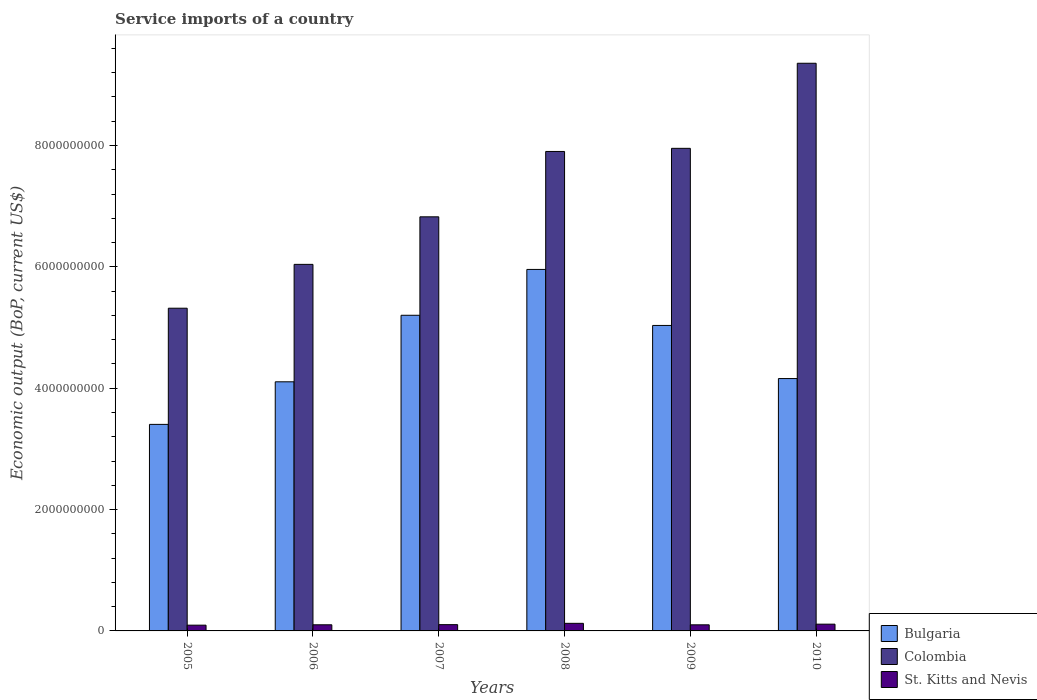How many different coloured bars are there?
Keep it short and to the point. 3. Are the number of bars per tick equal to the number of legend labels?
Your response must be concise. Yes. How many bars are there on the 4th tick from the right?
Make the answer very short. 3. What is the label of the 4th group of bars from the left?
Provide a short and direct response. 2008. In how many cases, is the number of bars for a given year not equal to the number of legend labels?
Your answer should be compact. 0. What is the service imports in Bulgaria in 2009?
Your response must be concise. 5.03e+09. Across all years, what is the maximum service imports in Bulgaria?
Ensure brevity in your answer.  5.96e+09. Across all years, what is the minimum service imports in Bulgaria?
Your answer should be compact. 3.40e+09. In which year was the service imports in Colombia maximum?
Your answer should be compact. 2010. In which year was the service imports in Bulgaria minimum?
Provide a succinct answer. 2005. What is the total service imports in Colombia in the graph?
Provide a succinct answer. 4.34e+1. What is the difference between the service imports in St. Kitts and Nevis in 2007 and that in 2009?
Keep it short and to the point. 2.91e+06. What is the difference between the service imports in Colombia in 2010 and the service imports in Bulgaria in 2006?
Offer a terse response. 5.25e+09. What is the average service imports in Bulgaria per year?
Your response must be concise. 4.64e+09. In the year 2009, what is the difference between the service imports in St. Kitts and Nevis and service imports in Colombia?
Offer a terse response. -7.85e+09. What is the ratio of the service imports in Bulgaria in 2006 to that in 2008?
Your answer should be compact. 0.69. What is the difference between the highest and the second highest service imports in Colombia?
Your response must be concise. 1.40e+09. What is the difference between the highest and the lowest service imports in Bulgaria?
Provide a short and direct response. 2.55e+09. In how many years, is the service imports in Bulgaria greater than the average service imports in Bulgaria taken over all years?
Offer a terse response. 3. Is the sum of the service imports in Bulgaria in 2005 and 2009 greater than the maximum service imports in Colombia across all years?
Give a very brief answer. No. What does the 3rd bar from the left in 2005 represents?
Offer a terse response. St. Kitts and Nevis. What does the 3rd bar from the right in 2009 represents?
Ensure brevity in your answer.  Bulgaria. Is it the case that in every year, the sum of the service imports in St. Kitts and Nevis and service imports in Bulgaria is greater than the service imports in Colombia?
Your response must be concise. No. Are all the bars in the graph horizontal?
Ensure brevity in your answer.  No. How many years are there in the graph?
Provide a succinct answer. 6. Does the graph contain grids?
Make the answer very short. No. Where does the legend appear in the graph?
Your response must be concise. Bottom right. How many legend labels are there?
Provide a short and direct response. 3. How are the legend labels stacked?
Ensure brevity in your answer.  Vertical. What is the title of the graph?
Your response must be concise. Service imports of a country. Does "El Salvador" appear as one of the legend labels in the graph?
Your response must be concise. No. What is the label or title of the Y-axis?
Your answer should be very brief. Economic output (BoP, current US$). What is the Economic output (BoP, current US$) of Bulgaria in 2005?
Your answer should be very brief. 3.40e+09. What is the Economic output (BoP, current US$) in Colombia in 2005?
Offer a terse response. 5.32e+09. What is the Economic output (BoP, current US$) in St. Kitts and Nevis in 2005?
Your response must be concise. 9.49e+07. What is the Economic output (BoP, current US$) of Bulgaria in 2006?
Offer a terse response. 4.11e+09. What is the Economic output (BoP, current US$) in Colombia in 2006?
Your answer should be compact. 6.04e+09. What is the Economic output (BoP, current US$) of St. Kitts and Nevis in 2006?
Keep it short and to the point. 1.01e+08. What is the Economic output (BoP, current US$) of Bulgaria in 2007?
Give a very brief answer. 5.20e+09. What is the Economic output (BoP, current US$) of Colombia in 2007?
Keep it short and to the point. 6.82e+09. What is the Economic output (BoP, current US$) of St. Kitts and Nevis in 2007?
Offer a terse response. 1.03e+08. What is the Economic output (BoP, current US$) in Bulgaria in 2008?
Provide a short and direct response. 5.96e+09. What is the Economic output (BoP, current US$) in Colombia in 2008?
Your answer should be compact. 7.90e+09. What is the Economic output (BoP, current US$) in St. Kitts and Nevis in 2008?
Your answer should be very brief. 1.25e+08. What is the Economic output (BoP, current US$) of Bulgaria in 2009?
Keep it short and to the point. 5.03e+09. What is the Economic output (BoP, current US$) in Colombia in 2009?
Provide a short and direct response. 7.95e+09. What is the Economic output (BoP, current US$) in St. Kitts and Nevis in 2009?
Offer a terse response. 1.00e+08. What is the Economic output (BoP, current US$) in Bulgaria in 2010?
Offer a very short reply. 4.16e+09. What is the Economic output (BoP, current US$) of Colombia in 2010?
Give a very brief answer. 9.36e+09. What is the Economic output (BoP, current US$) in St. Kitts and Nevis in 2010?
Make the answer very short. 1.11e+08. Across all years, what is the maximum Economic output (BoP, current US$) in Bulgaria?
Offer a very short reply. 5.96e+09. Across all years, what is the maximum Economic output (BoP, current US$) of Colombia?
Your response must be concise. 9.36e+09. Across all years, what is the maximum Economic output (BoP, current US$) in St. Kitts and Nevis?
Provide a succinct answer. 1.25e+08. Across all years, what is the minimum Economic output (BoP, current US$) of Bulgaria?
Provide a succinct answer. 3.40e+09. Across all years, what is the minimum Economic output (BoP, current US$) in Colombia?
Ensure brevity in your answer.  5.32e+09. Across all years, what is the minimum Economic output (BoP, current US$) in St. Kitts and Nevis?
Make the answer very short. 9.49e+07. What is the total Economic output (BoP, current US$) of Bulgaria in the graph?
Offer a very short reply. 2.79e+1. What is the total Economic output (BoP, current US$) of Colombia in the graph?
Your answer should be very brief. 4.34e+1. What is the total Economic output (BoP, current US$) in St. Kitts and Nevis in the graph?
Your answer should be very brief. 6.36e+08. What is the difference between the Economic output (BoP, current US$) in Bulgaria in 2005 and that in 2006?
Ensure brevity in your answer.  -7.02e+08. What is the difference between the Economic output (BoP, current US$) in Colombia in 2005 and that in 2006?
Offer a very short reply. -7.23e+08. What is the difference between the Economic output (BoP, current US$) in St. Kitts and Nevis in 2005 and that in 2006?
Your response must be concise. -6.20e+06. What is the difference between the Economic output (BoP, current US$) in Bulgaria in 2005 and that in 2007?
Keep it short and to the point. -1.80e+09. What is the difference between the Economic output (BoP, current US$) in Colombia in 2005 and that in 2007?
Give a very brief answer. -1.51e+09. What is the difference between the Economic output (BoP, current US$) of St. Kitts and Nevis in 2005 and that in 2007?
Your answer should be very brief. -8.45e+06. What is the difference between the Economic output (BoP, current US$) of Bulgaria in 2005 and that in 2008?
Keep it short and to the point. -2.55e+09. What is the difference between the Economic output (BoP, current US$) in Colombia in 2005 and that in 2008?
Offer a terse response. -2.58e+09. What is the difference between the Economic output (BoP, current US$) in St. Kitts and Nevis in 2005 and that in 2008?
Give a very brief answer. -3.02e+07. What is the difference between the Economic output (BoP, current US$) of Bulgaria in 2005 and that in 2009?
Offer a very short reply. -1.63e+09. What is the difference between the Economic output (BoP, current US$) in Colombia in 2005 and that in 2009?
Provide a short and direct response. -2.63e+09. What is the difference between the Economic output (BoP, current US$) in St. Kitts and Nevis in 2005 and that in 2009?
Your answer should be very brief. -5.54e+06. What is the difference between the Economic output (BoP, current US$) of Bulgaria in 2005 and that in 2010?
Your answer should be compact. -7.55e+08. What is the difference between the Economic output (BoP, current US$) in Colombia in 2005 and that in 2010?
Offer a very short reply. -4.04e+09. What is the difference between the Economic output (BoP, current US$) in St. Kitts and Nevis in 2005 and that in 2010?
Make the answer very short. -1.65e+07. What is the difference between the Economic output (BoP, current US$) in Bulgaria in 2006 and that in 2007?
Your answer should be very brief. -1.10e+09. What is the difference between the Economic output (BoP, current US$) in Colombia in 2006 and that in 2007?
Your response must be concise. -7.84e+08. What is the difference between the Economic output (BoP, current US$) in St. Kitts and Nevis in 2006 and that in 2007?
Your response must be concise. -2.25e+06. What is the difference between the Economic output (BoP, current US$) of Bulgaria in 2006 and that in 2008?
Make the answer very short. -1.85e+09. What is the difference between the Economic output (BoP, current US$) of Colombia in 2006 and that in 2008?
Your answer should be very brief. -1.86e+09. What is the difference between the Economic output (BoP, current US$) in St. Kitts and Nevis in 2006 and that in 2008?
Provide a short and direct response. -2.40e+07. What is the difference between the Economic output (BoP, current US$) of Bulgaria in 2006 and that in 2009?
Ensure brevity in your answer.  -9.29e+08. What is the difference between the Economic output (BoP, current US$) in Colombia in 2006 and that in 2009?
Your answer should be compact. -1.91e+09. What is the difference between the Economic output (BoP, current US$) in St. Kitts and Nevis in 2006 and that in 2009?
Give a very brief answer. 6.64e+05. What is the difference between the Economic output (BoP, current US$) in Bulgaria in 2006 and that in 2010?
Offer a terse response. -5.36e+07. What is the difference between the Economic output (BoP, current US$) of Colombia in 2006 and that in 2010?
Your answer should be compact. -3.31e+09. What is the difference between the Economic output (BoP, current US$) in St. Kitts and Nevis in 2006 and that in 2010?
Your answer should be compact. -1.03e+07. What is the difference between the Economic output (BoP, current US$) in Bulgaria in 2007 and that in 2008?
Keep it short and to the point. -7.55e+08. What is the difference between the Economic output (BoP, current US$) in Colombia in 2007 and that in 2008?
Offer a very short reply. -1.08e+09. What is the difference between the Economic output (BoP, current US$) in St. Kitts and Nevis in 2007 and that in 2008?
Your answer should be very brief. -2.17e+07. What is the difference between the Economic output (BoP, current US$) in Bulgaria in 2007 and that in 2009?
Make the answer very short. 1.68e+08. What is the difference between the Economic output (BoP, current US$) of Colombia in 2007 and that in 2009?
Make the answer very short. -1.13e+09. What is the difference between the Economic output (BoP, current US$) of St. Kitts and Nevis in 2007 and that in 2009?
Provide a succinct answer. 2.91e+06. What is the difference between the Economic output (BoP, current US$) in Bulgaria in 2007 and that in 2010?
Make the answer very short. 1.04e+09. What is the difference between the Economic output (BoP, current US$) in Colombia in 2007 and that in 2010?
Provide a succinct answer. -2.53e+09. What is the difference between the Economic output (BoP, current US$) in St. Kitts and Nevis in 2007 and that in 2010?
Provide a succinct answer. -8.01e+06. What is the difference between the Economic output (BoP, current US$) of Bulgaria in 2008 and that in 2009?
Give a very brief answer. 9.23e+08. What is the difference between the Economic output (BoP, current US$) in Colombia in 2008 and that in 2009?
Provide a succinct answer. -5.14e+07. What is the difference between the Economic output (BoP, current US$) in St. Kitts and Nevis in 2008 and that in 2009?
Make the answer very short. 2.46e+07. What is the difference between the Economic output (BoP, current US$) of Bulgaria in 2008 and that in 2010?
Offer a very short reply. 1.80e+09. What is the difference between the Economic output (BoP, current US$) in Colombia in 2008 and that in 2010?
Provide a short and direct response. -1.45e+09. What is the difference between the Economic output (BoP, current US$) in St. Kitts and Nevis in 2008 and that in 2010?
Make the answer very short. 1.37e+07. What is the difference between the Economic output (BoP, current US$) in Bulgaria in 2009 and that in 2010?
Your answer should be compact. 8.75e+08. What is the difference between the Economic output (BoP, current US$) of Colombia in 2009 and that in 2010?
Give a very brief answer. -1.40e+09. What is the difference between the Economic output (BoP, current US$) of St. Kitts and Nevis in 2009 and that in 2010?
Your answer should be compact. -1.09e+07. What is the difference between the Economic output (BoP, current US$) of Bulgaria in 2005 and the Economic output (BoP, current US$) of Colombia in 2006?
Provide a short and direct response. -2.64e+09. What is the difference between the Economic output (BoP, current US$) of Bulgaria in 2005 and the Economic output (BoP, current US$) of St. Kitts and Nevis in 2006?
Provide a succinct answer. 3.30e+09. What is the difference between the Economic output (BoP, current US$) in Colombia in 2005 and the Economic output (BoP, current US$) in St. Kitts and Nevis in 2006?
Give a very brief answer. 5.22e+09. What is the difference between the Economic output (BoP, current US$) of Bulgaria in 2005 and the Economic output (BoP, current US$) of Colombia in 2007?
Give a very brief answer. -3.42e+09. What is the difference between the Economic output (BoP, current US$) in Bulgaria in 2005 and the Economic output (BoP, current US$) in St. Kitts and Nevis in 2007?
Ensure brevity in your answer.  3.30e+09. What is the difference between the Economic output (BoP, current US$) in Colombia in 2005 and the Economic output (BoP, current US$) in St. Kitts and Nevis in 2007?
Give a very brief answer. 5.22e+09. What is the difference between the Economic output (BoP, current US$) of Bulgaria in 2005 and the Economic output (BoP, current US$) of Colombia in 2008?
Ensure brevity in your answer.  -4.50e+09. What is the difference between the Economic output (BoP, current US$) in Bulgaria in 2005 and the Economic output (BoP, current US$) in St. Kitts and Nevis in 2008?
Your answer should be very brief. 3.28e+09. What is the difference between the Economic output (BoP, current US$) of Colombia in 2005 and the Economic output (BoP, current US$) of St. Kitts and Nevis in 2008?
Give a very brief answer. 5.19e+09. What is the difference between the Economic output (BoP, current US$) of Bulgaria in 2005 and the Economic output (BoP, current US$) of Colombia in 2009?
Ensure brevity in your answer.  -4.55e+09. What is the difference between the Economic output (BoP, current US$) of Bulgaria in 2005 and the Economic output (BoP, current US$) of St. Kitts and Nevis in 2009?
Make the answer very short. 3.30e+09. What is the difference between the Economic output (BoP, current US$) of Colombia in 2005 and the Economic output (BoP, current US$) of St. Kitts and Nevis in 2009?
Make the answer very short. 5.22e+09. What is the difference between the Economic output (BoP, current US$) in Bulgaria in 2005 and the Economic output (BoP, current US$) in Colombia in 2010?
Ensure brevity in your answer.  -5.95e+09. What is the difference between the Economic output (BoP, current US$) in Bulgaria in 2005 and the Economic output (BoP, current US$) in St. Kitts and Nevis in 2010?
Ensure brevity in your answer.  3.29e+09. What is the difference between the Economic output (BoP, current US$) in Colombia in 2005 and the Economic output (BoP, current US$) in St. Kitts and Nevis in 2010?
Keep it short and to the point. 5.21e+09. What is the difference between the Economic output (BoP, current US$) of Bulgaria in 2006 and the Economic output (BoP, current US$) of Colombia in 2007?
Provide a short and direct response. -2.72e+09. What is the difference between the Economic output (BoP, current US$) of Bulgaria in 2006 and the Economic output (BoP, current US$) of St. Kitts and Nevis in 2007?
Make the answer very short. 4.00e+09. What is the difference between the Economic output (BoP, current US$) in Colombia in 2006 and the Economic output (BoP, current US$) in St. Kitts and Nevis in 2007?
Your response must be concise. 5.94e+09. What is the difference between the Economic output (BoP, current US$) of Bulgaria in 2006 and the Economic output (BoP, current US$) of Colombia in 2008?
Ensure brevity in your answer.  -3.80e+09. What is the difference between the Economic output (BoP, current US$) in Bulgaria in 2006 and the Economic output (BoP, current US$) in St. Kitts and Nevis in 2008?
Your answer should be very brief. 3.98e+09. What is the difference between the Economic output (BoP, current US$) of Colombia in 2006 and the Economic output (BoP, current US$) of St. Kitts and Nevis in 2008?
Your answer should be very brief. 5.92e+09. What is the difference between the Economic output (BoP, current US$) in Bulgaria in 2006 and the Economic output (BoP, current US$) in Colombia in 2009?
Keep it short and to the point. -3.85e+09. What is the difference between the Economic output (BoP, current US$) in Bulgaria in 2006 and the Economic output (BoP, current US$) in St. Kitts and Nevis in 2009?
Your answer should be very brief. 4.01e+09. What is the difference between the Economic output (BoP, current US$) of Colombia in 2006 and the Economic output (BoP, current US$) of St. Kitts and Nevis in 2009?
Your response must be concise. 5.94e+09. What is the difference between the Economic output (BoP, current US$) of Bulgaria in 2006 and the Economic output (BoP, current US$) of Colombia in 2010?
Give a very brief answer. -5.25e+09. What is the difference between the Economic output (BoP, current US$) of Bulgaria in 2006 and the Economic output (BoP, current US$) of St. Kitts and Nevis in 2010?
Provide a succinct answer. 3.99e+09. What is the difference between the Economic output (BoP, current US$) of Colombia in 2006 and the Economic output (BoP, current US$) of St. Kitts and Nevis in 2010?
Provide a succinct answer. 5.93e+09. What is the difference between the Economic output (BoP, current US$) in Bulgaria in 2007 and the Economic output (BoP, current US$) in Colombia in 2008?
Offer a very short reply. -2.70e+09. What is the difference between the Economic output (BoP, current US$) of Bulgaria in 2007 and the Economic output (BoP, current US$) of St. Kitts and Nevis in 2008?
Your response must be concise. 5.08e+09. What is the difference between the Economic output (BoP, current US$) of Colombia in 2007 and the Economic output (BoP, current US$) of St. Kitts and Nevis in 2008?
Make the answer very short. 6.70e+09. What is the difference between the Economic output (BoP, current US$) in Bulgaria in 2007 and the Economic output (BoP, current US$) in Colombia in 2009?
Ensure brevity in your answer.  -2.75e+09. What is the difference between the Economic output (BoP, current US$) of Bulgaria in 2007 and the Economic output (BoP, current US$) of St. Kitts and Nevis in 2009?
Give a very brief answer. 5.10e+09. What is the difference between the Economic output (BoP, current US$) in Colombia in 2007 and the Economic output (BoP, current US$) in St. Kitts and Nevis in 2009?
Ensure brevity in your answer.  6.72e+09. What is the difference between the Economic output (BoP, current US$) of Bulgaria in 2007 and the Economic output (BoP, current US$) of Colombia in 2010?
Your response must be concise. -4.15e+09. What is the difference between the Economic output (BoP, current US$) of Bulgaria in 2007 and the Economic output (BoP, current US$) of St. Kitts and Nevis in 2010?
Your response must be concise. 5.09e+09. What is the difference between the Economic output (BoP, current US$) of Colombia in 2007 and the Economic output (BoP, current US$) of St. Kitts and Nevis in 2010?
Ensure brevity in your answer.  6.71e+09. What is the difference between the Economic output (BoP, current US$) of Bulgaria in 2008 and the Economic output (BoP, current US$) of Colombia in 2009?
Make the answer very short. -2.00e+09. What is the difference between the Economic output (BoP, current US$) in Bulgaria in 2008 and the Economic output (BoP, current US$) in St. Kitts and Nevis in 2009?
Ensure brevity in your answer.  5.86e+09. What is the difference between the Economic output (BoP, current US$) of Colombia in 2008 and the Economic output (BoP, current US$) of St. Kitts and Nevis in 2009?
Offer a very short reply. 7.80e+09. What is the difference between the Economic output (BoP, current US$) of Bulgaria in 2008 and the Economic output (BoP, current US$) of Colombia in 2010?
Ensure brevity in your answer.  -3.40e+09. What is the difference between the Economic output (BoP, current US$) of Bulgaria in 2008 and the Economic output (BoP, current US$) of St. Kitts and Nevis in 2010?
Make the answer very short. 5.85e+09. What is the difference between the Economic output (BoP, current US$) in Colombia in 2008 and the Economic output (BoP, current US$) in St. Kitts and Nevis in 2010?
Offer a terse response. 7.79e+09. What is the difference between the Economic output (BoP, current US$) of Bulgaria in 2009 and the Economic output (BoP, current US$) of Colombia in 2010?
Provide a short and direct response. -4.32e+09. What is the difference between the Economic output (BoP, current US$) of Bulgaria in 2009 and the Economic output (BoP, current US$) of St. Kitts and Nevis in 2010?
Provide a short and direct response. 4.92e+09. What is the difference between the Economic output (BoP, current US$) in Colombia in 2009 and the Economic output (BoP, current US$) in St. Kitts and Nevis in 2010?
Offer a terse response. 7.84e+09. What is the average Economic output (BoP, current US$) in Bulgaria per year?
Provide a succinct answer. 4.64e+09. What is the average Economic output (BoP, current US$) in Colombia per year?
Ensure brevity in your answer.  7.23e+09. What is the average Economic output (BoP, current US$) of St. Kitts and Nevis per year?
Make the answer very short. 1.06e+08. In the year 2005, what is the difference between the Economic output (BoP, current US$) of Bulgaria and Economic output (BoP, current US$) of Colombia?
Your response must be concise. -1.91e+09. In the year 2005, what is the difference between the Economic output (BoP, current US$) in Bulgaria and Economic output (BoP, current US$) in St. Kitts and Nevis?
Your response must be concise. 3.31e+09. In the year 2005, what is the difference between the Economic output (BoP, current US$) of Colombia and Economic output (BoP, current US$) of St. Kitts and Nevis?
Your answer should be compact. 5.22e+09. In the year 2006, what is the difference between the Economic output (BoP, current US$) of Bulgaria and Economic output (BoP, current US$) of Colombia?
Make the answer very short. -1.94e+09. In the year 2006, what is the difference between the Economic output (BoP, current US$) in Bulgaria and Economic output (BoP, current US$) in St. Kitts and Nevis?
Ensure brevity in your answer.  4.00e+09. In the year 2006, what is the difference between the Economic output (BoP, current US$) of Colombia and Economic output (BoP, current US$) of St. Kitts and Nevis?
Offer a terse response. 5.94e+09. In the year 2007, what is the difference between the Economic output (BoP, current US$) in Bulgaria and Economic output (BoP, current US$) in Colombia?
Your response must be concise. -1.62e+09. In the year 2007, what is the difference between the Economic output (BoP, current US$) in Bulgaria and Economic output (BoP, current US$) in St. Kitts and Nevis?
Offer a very short reply. 5.10e+09. In the year 2007, what is the difference between the Economic output (BoP, current US$) in Colombia and Economic output (BoP, current US$) in St. Kitts and Nevis?
Provide a short and direct response. 6.72e+09. In the year 2008, what is the difference between the Economic output (BoP, current US$) of Bulgaria and Economic output (BoP, current US$) of Colombia?
Keep it short and to the point. -1.94e+09. In the year 2008, what is the difference between the Economic output (BoP, current US$) in Bulgaria and Economic output (BoP, current US$) in St. Kitts and Nevis?
Offer a very short reply. 5.83e+09. In the year 2008, what is the difference between the Economic output (BoP, current US$) in Colombia and Economic output (BoP, current US$) in St. Kitts and Nevis?
Provide a short and direct response. 7.78e+09. In the year 2009, what is the difference between the Economic output (BoP, current US$) of Bulgaria and Economic output (BoP, current US$) of Colombia?
Make the answer very short. -2.92e+09. In the year 2009, what is the difference between the Economic output (BoP, current US$) in Bulgaria and Economic output (BoP, current US$) in St. Kitts and Nevis?
Give a very brief answer. 4.93e+09. In the year 2009, what is the difference between the Economic output (BoP, current US$) in Colombia and Economic output (BoP, current US$) in St. Kitts and Nevis?
Your response must be concise. 7.85e+09. In the year 2010, what is the difference between the Economic output (BoP, current US$) of Bulgaria and Economic output (BoP, current US$) of Colombia?
Your answer should be compact. -5.20e+09. In the year 2010, what is the difference between the Economic output (BoP, current US$) in Bulgaria and Economic output (BoP, current US$) in St. Kitts and Nevis?
Offer a terse response. 4.05e+09. In the year 2010, what is the difference between the Economic output (BoP, current US$) of Colombia and Economic output (BoP, current US$) of St. Kitts and Nevis?
Provide a succinct answer. 9.24e+09. What is the ratio of the Economic output (BoP, current US$) in Bulgaria in 2005 to that in 2006?
Keep it short and to the point. 0.83. What is the ratio of the Economic output (BoP, current US$) of Colombia in 2005 to that in 2006?
Make the answer very short. 0.88. What is the ratio of the Economic output (BoP, current US$) in St. Kitts and Nevis in 2005 to that in 2006?
Your response must be concise. 0.94. What is the ratio of the Economic output (BoP, current US$) in Bulgaria in 2005 to that in 2007?
Your answer should be very brief. 0.65. What is the ratio of the Economic output (BoP, current US$) of Colombia in 2005 to that in 2007?
Provide a succinct answer. 0.78. What is the ratio of the Economic output (BoP, current US$) in St. Kitts and Nevis in 2005 to that in 2007?
Ensure brevity in your answer.  0.92. What is the ratio of the Economic output (BoP, current US$) of Bulgaria in 2005 to that in 2008?
Your answer should be compact. 0.57. What is the ratio of the Economic output (BoP, current US$) of Colombia in 2005 to that in 2008?
Provide a short and direct response. 0.67. What is the ratio of the Economic output (BoP, current US$) of St. Kitts and Nevis in 2005 to that in 2008?
Offer a terse response. 0.76. What is the ratio of the Economic output (BoP, current US$) in Bulgaria in 2005 to that in 2009?
Offer a very short reply. 0.68. What is the ratio of the Economic output (BoP, current US$) in Colombia in 2005 to that in 2009?
Keep it short and to the point. 0.67. What is the ratio of the Economic output (BoP, current US$) in St. Kitts and Nevis in 2005 to that in 2009?
Your response must be concise. 0.94. What is the ratio of the Economic output (BoP, current US$) of Bulgaria in 2005 to that in 2010?
Provide a succinct answer. 0.82. What is the ratio of the Economic output (BoP, current US$) in Colombia in 2005 to that in 2010?
Keep it short and to the point. 0.57. What is the ratio of the Economic output (BoP, current US$) of St. Kitts and Nevis in 2005 to that in 2010?
Your answer should be compact. 0.85. What is the ratio of the Economic output (BoP, current US$) in Bulgaria in 2006 to that in 2007?
Give a very brief answer. 0.79. What is the ratio of the Economic output (BoP, current US$) of Colombia in 2006 to that in 2007?
Your answer should be compact. 0.89. What is the ratio of the Economic output (BoP, current US$) of St. Kitts and Nevis in 2006 to that in 2007?
Ensure brevity in your answer.  0.98. What is the ratio of the Economic output (BoP, current US$) of Bulgaria in 2006 to that in 2008?
Keep it short and to the point. 0.69. What is the ratio of the Economic output (BoP, current US$) of Colombia in 2006 to that in 2008?
Your answer should be compact. 0.76. What is the ratio of the Economic output (BoP, current US$) in St. Kitts and Nevis in 2006 to that in 2008?
Your answer should be very brief. 0.81. What is the ratio of the Economic output (BoP, current US$) in Bulgaria in 2006 to that in 2009?
Give a very brief answer. 0.82. What is the ratio of the Economic output (BoP, current US$) of Colombia in 2006 to that in 2009?
Keep it short and to the point. 0.76. What is the ratio of the Economic output (BoP, current US$) in St. Kitts and Nevis in 2006 to that in 2009?
Your response must be concise. 1.01. What is the ratio of the Economic output (BoP, current US$) of Bulgaria in 2006 to that in 2010?
Provide a succinct answer. 0.99. What is the ratio of the Economic output (BoP, current US$) of Colombia in 2006 to that in 2010?
Provide a succinct answer. 0.65. What is the ratio of the Economic output (BoP, current US$) of St. Kitts and Nevis in 2006 to that in 2010?
Ensure brevity in your answer.  0.91. What is the ratio of the Economic output (BoP, current US$) in Bulgaria in 2007 to that in 2008?
Make the answer very short. 0.87. What is the ratio of the Economic output (BoP, current US$) in Colombia in 2007 to that in 2008?
Your response must be concise. 0.86. What is the ratio of the Economic output (BoP, current US$) of St. Kitts and Nevis in 2007 to that in 2008?
Your response must be concise. 0.83. What is the ratio of the Economic output (BoP, current US$) of Colombia in 2007 to that in 2009?
Keep it short and to the point. 0.86. What is the ratio of the Economic output (BoP, current US$) of Bulgaria in 2007 to that in 2010?
Your answer should be compact. 1.25. What is the ratio of the Economic output (BoP, current US$) in Colombia in 2007 to that in 2010?
Your answer should be very brief. 0.73. What is the ratio of the Economic output (BoP, current US$) of St. Kitts and Nevis in 2007 to that in 2010?
Make the answer very short. 0.93. What is the ratio of the Economic output (BoP, current US$) of Bulgaria in 2008 to that in 2009?
Your answer should be compact. 1.18. What is the ratio of the Economic output (BoP, current US$) in St. Kitts and Nevis in 2008 to that in 2009?
Your answer should be compact. 1.25. What is the ratio of the Economic output (BoP, current US$) of Bulgaria in 2008 to that in 2010?
Make the answer very short. 1.43. What is the ratio of the Economic output (BoP, current US$) in Colombia in 2008 to that in 2010?
Your answer should be very brief. 0.84. What is the ratio of the Economic output (BoP, current US$) in St. Kitts and Nevis in 2008 to that in 2010?
Keep it short and to the point. 1.12. What is the ratio of the Economic output (BoP, current US$) in Bulgaria in 2009 to that in 2010?
Make the answer very short. 1.21. What is the ratio of the Economic output (BoP, current US$) in Colombia in 2009 to that in 2010?
Make the answer very short. 0.85. What is the ratio of the Economic output (BoP, current US$) in St. Kitts and Nevis in 2009 to that in 2010?
Make the answer very short. 0.9. What is the difference between the highest and the second highest Economic output (BoP, current US$) in Bulgaria?
Your answer should be compact. 7.55e+08. What is the difference between the highest and the second highest Economic output (BoP, current US$) in Colombia?
Your answer should be compact. 1.40e+09. What is the difference between the highest and the second highest Economic output (BoP, current US$) in St. Kitts and Nevis?
Provide a succinct answer. 1.37e+07. What is the difference between the highest and the lowest Economic output (BoP, current US$) of Bulgaria?
Offer a very short reply. 2.55e+09. What is the difference between the highest and the lowest Economic output (BoP, current US$) of Colombia?
Provide a succinct answer. 4.04e+09. What is the difference between the highest and the lowest Economic output (BoP, current US$) of St. Kitts and Nevis?
Offer a very short reply. 3.02e+07. 